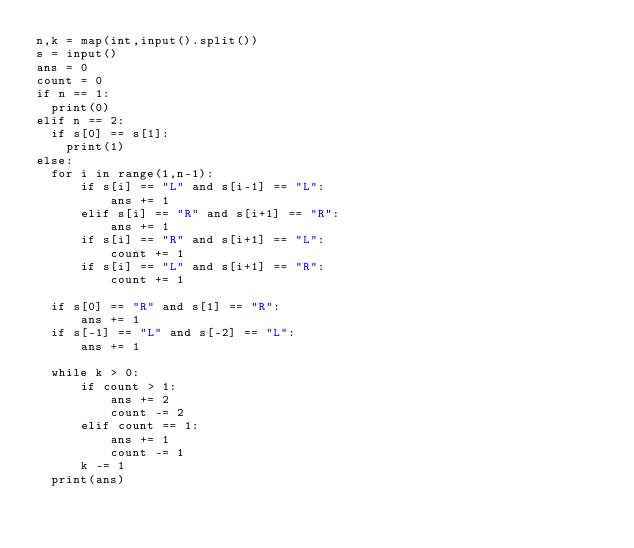Convert code to text. <code><loc_0><loc_0><loc_500><loc_500><_Python_>n,k = map(int,input().split())
s = input()
ans = 0
count = 0
if n == 1:
  print(0)
elif n == 2:
  if s[0] == s[1]:
    print(1)
else:
  for i in range(1,n-1):
      if s[i] == "L" and s[i-1] == "L":
          ans += 1
      elif s[i] == "R" and s[i+1] == "R":
          ans += 1
      if s[i] == "R" and s[i+1] == "L":
          count += 1
      if s[i] == "L" and s[i+1] == "R":
          count += 1

  if s[0] == "R" and s[1] == "R":
      ans += 1
  if s[-1] == "L" and s[-2] == "L":
      ans += 1

  while k > 0:
      if count > 1:
          ans += 2
          count -= 2
      elif count == 1:
          ans += 1
          count -= 1
      k -= 1
  print(ans)
</code> 